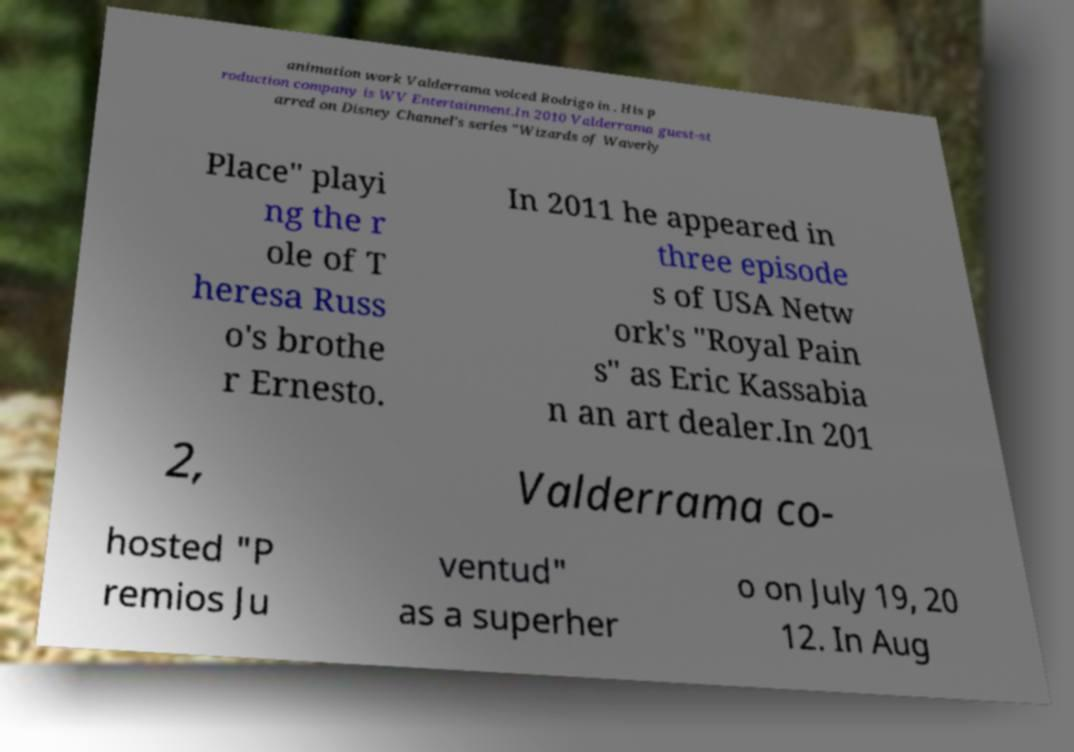For documentation purposes, I need the text within this image transcribed. Could you provide that? animation work Valderrama voiced Rodrigo in . His p roduction company is WV Entertainment.In 2010 Valderrama guest-st arred on Disney Channel's series "Wizards of Waverly Place" playi ng the r ole of T heresa Russ o's brothe r Ernesto. In 2011 he appeared in three episode s of USA Netw ork's "Royal Pain s" as Eric Kassabia n an art dealer.In 201 2, Valderrama co- hosted "P remios Ju ventud" as a superher o on July 19, 20 12. In Aug 